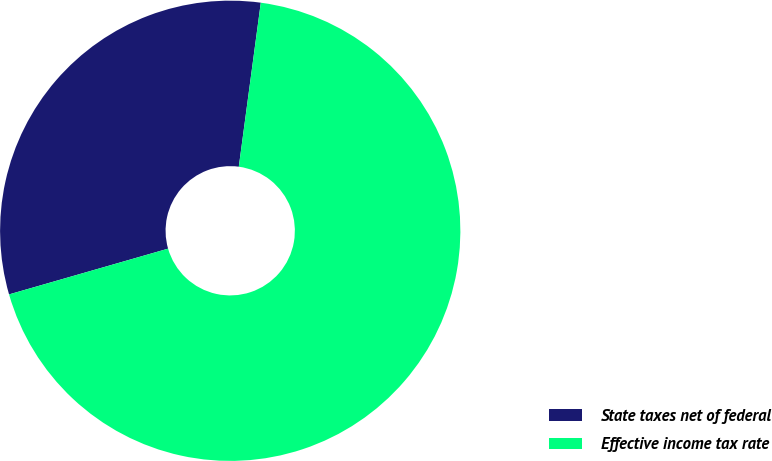Convert chart to OTSL. <chart><loc_0><loc_0><loc_500><loc_500><pie_chart><fcel>State taxes net of federal<fcel>Effective income tax rate<nl><fcel>31.58%<fcel>68.42%<nl></chart> 